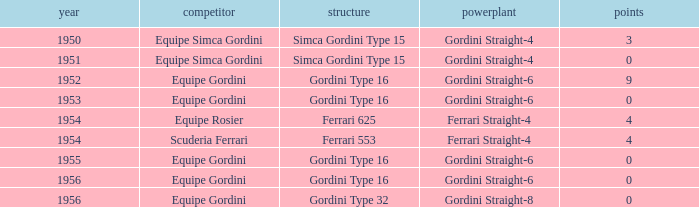What chassis has smaller than 9 points by Equipe Rosier? Ferrari 625. 